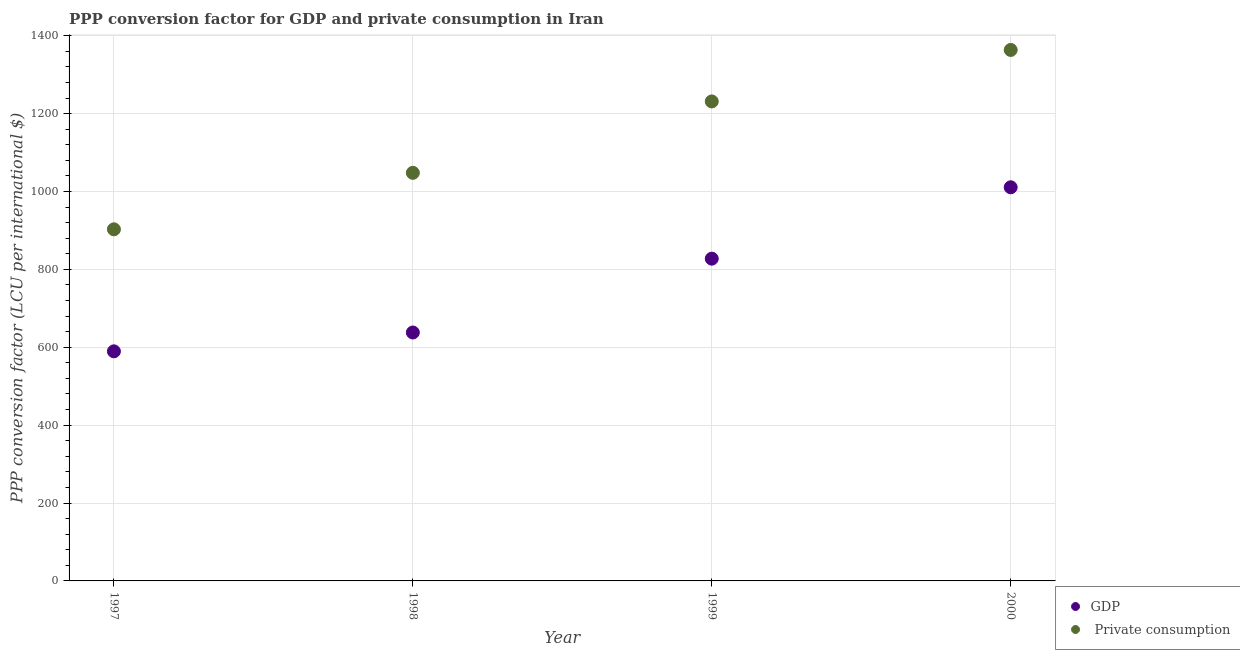Is the number of dotlines equal to the number of legend labels?
Give a very brief answer. Yes. What is the ppp conversion factor for gdp in 1997?
Keep it short and to the point. 589.52. Across all years, what is the maximum ppp conversion factor for gdp?
Your answer should be very brief. 1010.8. Across all years, what is the minimum ppp conversion factor for gdp?
Your answer should be very brief. 589.52. In which year was the ppp conversion factor for gdp maximum?
Your response must be concise. 2000. What is the total ppp conversion factor for gdp in the graph?
Give a very brief answer. 3065.74. What is the difference between the ppp conversion factor for gdp in 1997 and that in 1998?
Offer a very short reply. -48.38. What is the difference between the ppp conversion factor for gdp in 1998 and the ppp conversion factor for private consumption in 2000?
Your answer should be very brief. -725.56. What is the average ppp conversion factor for gdp per year?
Make the answer very short. 766.43. In the year 1999, what is the difference between the ppp conversion factor for private consumption and ppp conversion factor for gdp?
Your answer should be very brief. 403.75. In how many years, is the ppp conversion factor for private consumption greater than 400 LCU?
Make the answer very short. 4. What is the ratio of the ppp conversion factor for private consumption in 1998 to that in 2000?
Your answer should be very brief. 0.77. Is the difference between the ppp conversion factor for private consumption in 1997 and 1999 greater than the difference between the ppp conversion factor for gdp in 1997 and 1999?
Give a very brief answer. No. What is the difference between the highest and the second highest ppp conversion factor for private consumption?
Offer a terse response. 132.2. What is the difference between the highest and the lowest ppp conversion factor for private consumption?
Provide a short and direct response. 460.62. Does the ppp conversion factor for gdp monotonically increase over the years?
Your answer should be compact. Yes. How many years are there in the graph?
Make the answer very short. 4. What is the difference between two consecutive major ticks on the Y-axis?
Provide a succinct answer. 200. Does the graph contain any zero values?
Give a very brief answer. No. Where does the legend appear in the graph?
Offer a very short reply. Bottom right. How many legend labels are there?
Ensure brevity in your answer.  2. What is the title of the graph?
Your answer should be very brief. PPP conversion factor for GDP and private consumption in Iran. Does "Rural Population" appear as one of the legend labels in the graph?
Offer a terse response. No. What is the label or title of the Y-axis?
Ensure brevity in your answer.  PPP conversion factor (LCU per international $). What is the PPP conversion factor (LCU per international $) of GDP in 1997?
Your response must be concise. 589.52. What is the PPP conversion factor (LCU per international $) in  Private consumption in 1997?
Ensure brevity in your answer.  902.85. What is the PPP conversion factor (LCU per international $) in GDP in 1998?
Provide a succinct answer. 637.91. What is the PPP conversion factor (LCU per international $) in  Private consumption in 1998?
Your response must be concise. 1047.88. What is the PPP conversion factor (LCU per international $) of GDP in 1999?
Provide a short and direct response. 827.51. What is the PPP conversion factor (LCU per international $) in  Private consumption in 1999?
Offer a terse response. 1231.26. What is the PPP conversion factor (LCU per international $) in GDP in 2000?
Give a very brief answer. 1010.8. What is the PPP conversion factor (LCU per international $) in  Private consumption in 2000?
Provide a succinct answer. 1363.47. Across all years, what is the maximum PPP conversion factor (LCU per international $) in GDP?
Your response must be concise. 1010.8. Across all years, what is the maximum PPP conversion factor (LCU per international $) of  Private consumption?
Keep it short and to the point. 1363.47. Across all years, what is the minimum PPP conversion factor (LCU per international $) in GDP?
Your answer should be very brief. 589.52. Across all years, what is the minimum PPP conversion factor (LCU per international $) in  Private consumption?
Your answer should be compact. 902.85. What is the total PPP conversion factor (LCU per international $) in GDP in the graph?
Your response must be concise. 3065.74. What is the total PPP conversion factor (LCU per international $) in  Private consumption in the graph?
Provide a short and direct response. 4545.46. What is the difference between the PPP conversion factor (LCU per international $) of GDP in 1997 and that in 1998?
Give a very brief answer. -48.38. What is the difference between the PPP conversion factor (LCU per international $) of  Private consumption in 1997 and that in 1998?
Your answer should be compact. -145.04. What is the difference between the PPP conversion factor (LCU per international $) of GDP in 1997 and that in 1999?
Your answer should be very brief. -237.99. What is the difference between the PPP conversion factor (LCU per international $) of  Private consumption in 1997 and that in 1999?
Your answer should be compact. -328.42. What is the difference between the PPP conversion factor (LCU per international $) of GDP in 1997 and that in 2000?
Give a very brief answer. -421.28. What is the difference between the PPP conversion factor (LCU per international $) of  Private consumption in 1997 and that in 2000?
Your response must be concise. -460.62. What is the difference between the PPP conversion factor (LCU per international $) in GDP in 1998 and that in 1999?
Offer a terse response. -189.6. What is the difference between the PPP conversion factor (LCU per international $) in  Private consumption in 1998 and that in 1999?
Offer a very short reply. -183.38. What is the difference between the PPP conversion factor (LCU per international $) of GDP in 1998 and that in 2000?
Ensure brevity in your answer.  -372.89. What is the difference between the PPP conversion factor (LCU per international $) of  Private consumption in 1998 and that in 2000?
Keep it short and to the point. -315.58. What is the difference between the PPP conversion factor (LCU per international $) in GDP in 1999 and that in 2000?
Offer a terse response. -183.29. What is the difference between the PPP conversion factor (LCU per international $) of  Private consumption in 1999 and that in 2000?
Make the answer very short. -132.2. What is the difference between the PPP conversion factor (LCU per international $) of GDP in 1997 and the PPP conversion factor (LCU per international $) of  Private consumption in 1998?
Ensure brevity in your answer.  -458.36. What is the difference between the PPP conversion factor (LCU per international $) in GDP in 1997 and the PPP conversion factor (LCU per international $) in  Private consumption in 1999?
Make the answer very short. -641.74. What is the difference between the PPP conversion factor (LCU per international $) in GDP in 1997 and the PPP conversion factor (LCU per international $) in  Private consumption in 2000?
Your response must be concise. -773.94. What is the difference between the PPP conversion factor (LCU per international $) of GDP in 1998 and the PPP conversion factor (LCU per international $) of  Private consumption in 1999?
Keep it short and to the point. -593.36. What is the difference between the PPP conversion factor (LCU per international $) of GDP in 1998 and the PPP conversion factor (LCU per international $) of  Private consumption in 2000?
Your answer should be compact. -725.56. What is the difference between the PPP conversion factor (LCU per international $) of GDP in 1999 and the PPP conversion factor (LCU per international $) of  Private consumption in 2000?
Your response must be concise. -535.96. What is the average PPP conversion factor (LCU per international $) of GDP per year?
Offer a very short reply. 766.43. What is the average PPP conversion factor (LCU per international $) in  Private consumption per year?
Make the answer very short. 1136.36. In the year 1997, what is the difference between the PPP conversion factor (LCU per international $) in GDP and PPP conversion factor (LCU per international $) in  Private consumption?
Offer a very short reply. -313.32. In the year 1998, what is the difference between the PPP conversion factor (LCU per international $) in GDP and PPP conversion factor (LCU per international $) in  Private consumption?
Your answer should be compact. -409.98. In the year 1999, what is the difference between the PPP conversion factor (LCU per international $) of GDP and PPP conversion factor (LCU per international $) of  Private consumption?
Give a very brief answer. -403.75. In the year 2000, what is the difference between the PPP conversion factor (LCU per international $) in GDP and PPP conversion factor (LCU per international $) in  Private consumption?
Give a very brief answer. -352.67. What is the ratio of the PPP conversion factor (LCU per international $) of GDP in 1997 to that in 1998?
Ensure brevity in your answer.  0.92. What is the ratio of the PPP conversion factor (LCU per international $) of  Private consumption in 1997 to that in 1998?
Give a very brief answer. 0.86. What is the ratio of the PPP conversion factor (LCU per international $) of GDP in 1997 to that in 1999?
Offer a very short reply. 0.71. What is the ratio of the PPP conversion factor (LCU per international $) in  Private consumption in 1997 to that in 1999?
Your answer should be very brief. 0.73. What is the ratio of the PPP conversion factor (LCU per international $) in GDP in 1997 to that in 2000?
Your answer should be very brief. 0.58. What is the ratio of the PPP conversion factor (LCU per international $) in  Private consumption in 1997 to that in 2000?
Keep it short and to the point. 0.66. What is the ratio of the PPP conversion factor (LCU per international $) in GDP in 1998 to that in 1999?
Offer a very short reply. 0.77. What is the ratio of the PPP conversion factor (LCU per international $) of  Private consumption in 1998 to that in 1999?
Your response must be concise. 0.85. What is the ratio of the PPP conversion factor (LCU per international $) of GDP in 1998 to that in 2000?
Give a very brief answer. 0.63. What is the ratio of the PPP conversion factor (LCU per international $) of  Private consumption in 1998 to that in 2000?
Your answer should be compact. 0.77. What is the ratio of the PPP conversion factor (LCU per international $) in GDP in 1999 to that in 2000?
Your response must be concise. 0.82. What is the ratio of the PPP conversion factor (LCU per international $) of  Private consumption in 1999 to that in 2000?
Offer a very short reply. 0.9. What is the difference between the highest and the second highest PPP conversion factor (LCU per international $) of GDP?
Provide a succinct answer. 183.29. What is the difference between the highest and the second highest PPP conversion factor (LCU per international $) of  Private consumption?
Your response must be concise. 132.2. What is the difference between the highest and the lowest PPP conversion factor (LCU per international $) in GDP?
Provide a short and direct response. 421.28. What is the difference between the highest and the lowest PPP conversion factor (LCU per international $) of  Private consumption?
Ensure brevity in your answer.  460.62. 